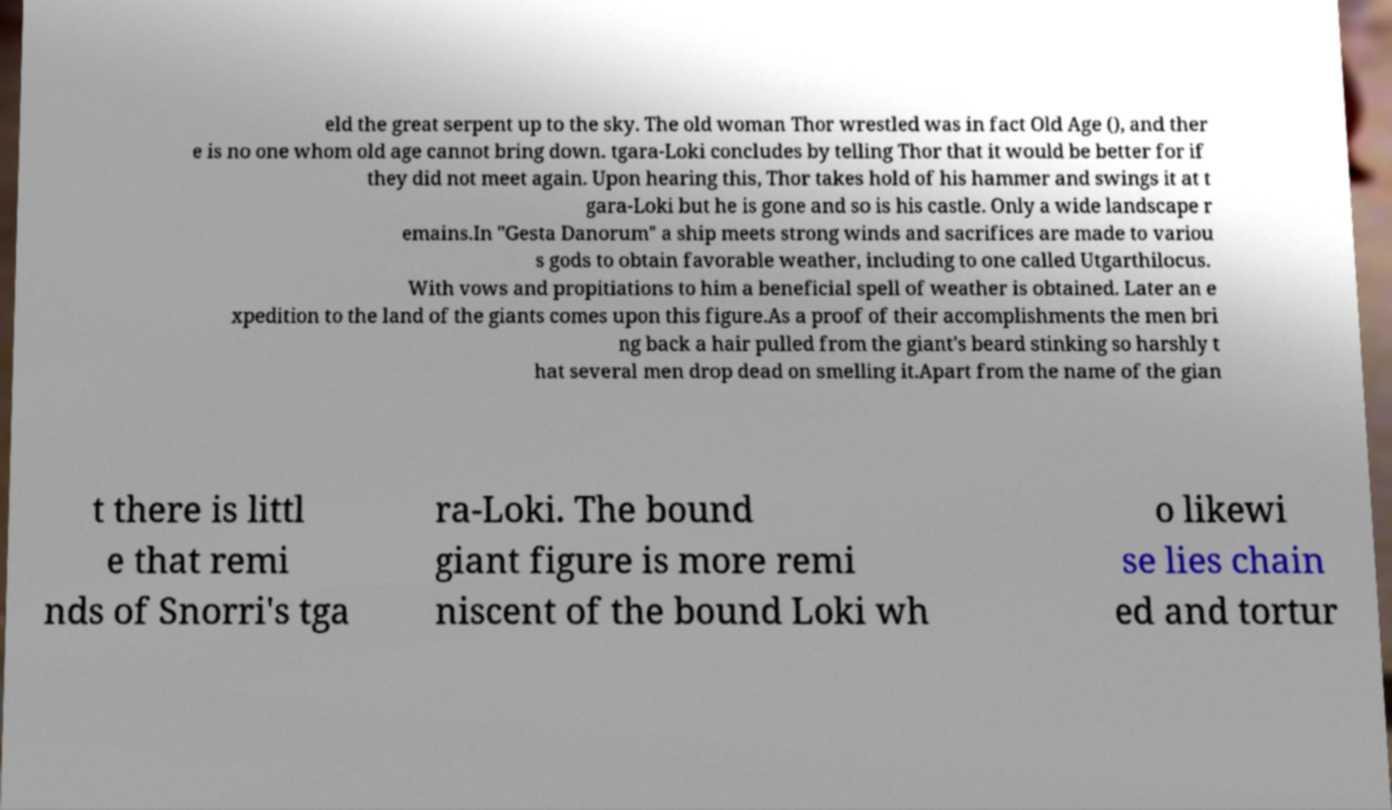Can you accurately transcribe the text from the provided image for me? eld the great serpent up to the sky. The old woman Thor wrestled was in fact Old Age (), and ther e is no one whom old age cannot bring down. tgara-Loki concludes by telling Thor that it would be better for if they did not meet again. Upon hearing this, Thor takes hold of his hammer and swings it at t gara-Loki but he is gone and so is his castle. Only a wide landscape r emains.In "Gesta Danorum" a ship meets strong winds and sacrifices are made to variou s gods to obtain favorable weather, including to one called Utgarthilocus. With vows and propitiations to him a beneficial spell of weather is obtained. Later an e xpedition to the land of the giants comes upon this figure.As a proof of their accomplishments the men bri ng back a hair pulled from the giant's beard stinking so harshly t hat several men drop dead on smelling it.Apart from the name of the gian t there is littl e that remi nds of Snorri's tga ra-Loki. The bound giant figure is more remi niscent of the bound Loki wh o likewi se lies chain ed and tortur 